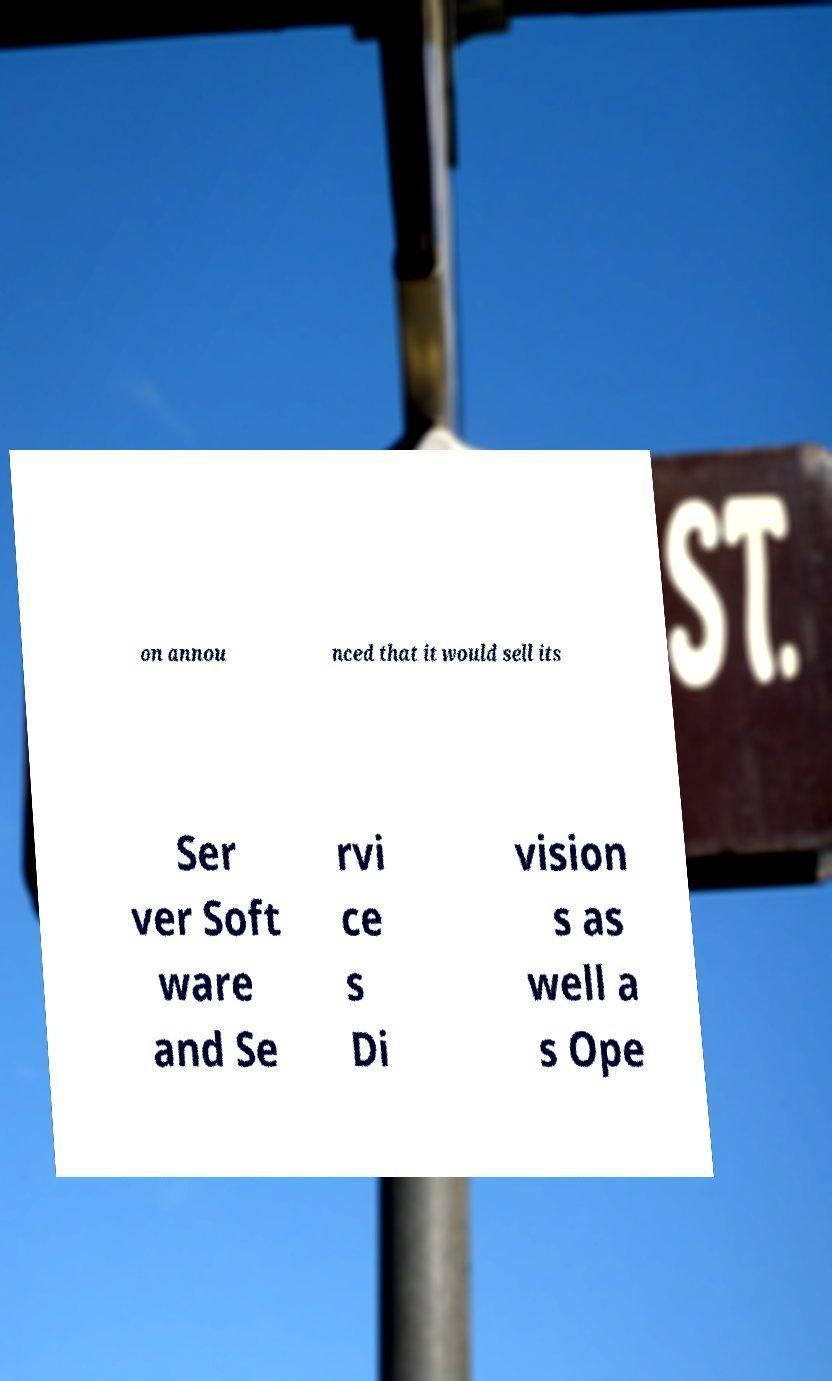Please read and relay the text visible in this image. What does it say? on annou nced that it would sell its Ser ver Soft ware and Se rvi ce s Di vision s as well a s Ope 